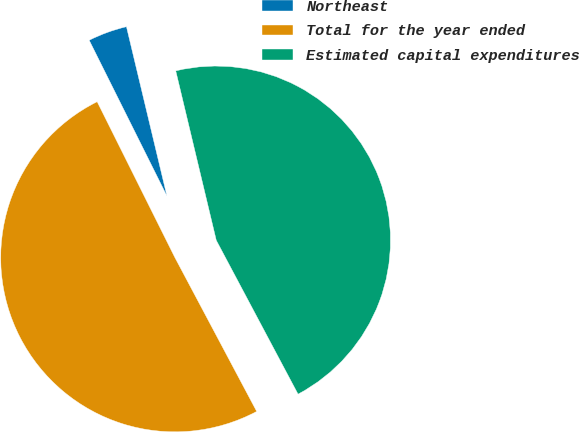Convert chart. <chart><loc_0><loc_0><loc_500><loc_500><pie_chart><fcel>Northeast<fcel>Total for the year ended<fcel>Estimated capital expenditures<nl><fcel>3.63%<fcel>50.41%<fcel>45.96%<nl></chart> 